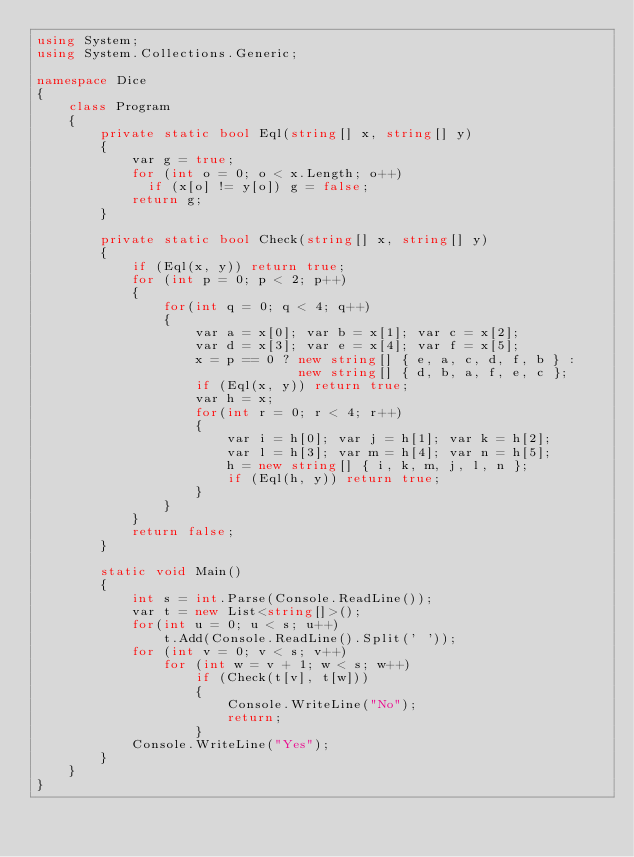<code> <loc_0><loc_0><loc_500><loc_500><_C#_>using System;
using System.Collections.Generic;

namespace Dice
{
    class Program
    {
        private static bool Eql(string[] x, string[] y)
        {
            var g = true;
            for (int o = 0; o < x.Length; o++)
              if (x[o] != y[o]) g = false;
            return g;
        }

        private static bool Check(string[] x, string[] y)
        {
            if (Eql(x, y)) return true;
            for (int p = 0; p < 2; p++)
            {
                for(int q = 0; q < 4; q++)
                {
                    var a = x[0]; var b = x[1]; var c = x[2];
                    var d = x[3]; var e = x[4]; var f = x[5];
                    x = p == 0 ? new string[] { e, a, c, d, f, b } :
                                 new string[] { d, b, a, f, e, c };
                    if (Eql(x, y)) return true;
                    var h = x;
                    for(int r = 0; r < 4; r++)
                    {
                        var i = h[0]; var j = h[1]; var k = h[2];
                        var l = h[3]; var m = h[4]; var n = h[5];
                        h = new string[] { i, k, m, j, l, n };
                        if (Eql(h, y)) return true;
                    }
                }
            }
            return false;
        }

        static void Main()
        {
            int s = int.Parse(Console.ReadLine());
            var t = new List<string[]>();
            for(int u = 0; u < s; u++)
                t.Add(Console.ReadLine().Split(' '));
            for (int v = 0; v < s; v++)
                for (int w = v + 1; w < s; w++)
                    if (Check(t[v], t[w]))
                    {
                        Console.WriteLine("No");
                        return;
                    }
            Console.WriteLine("Yes");
        }
    }
}</code> 